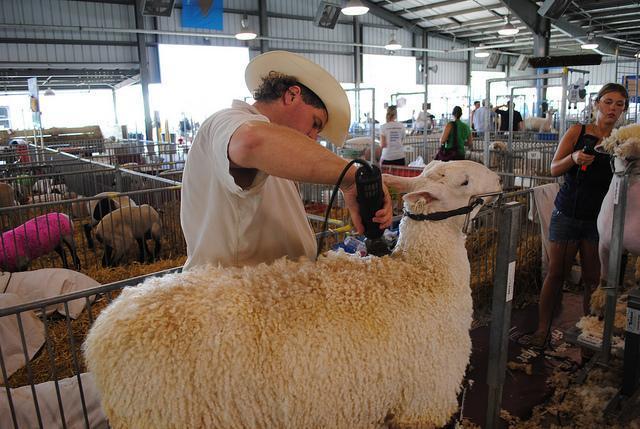How many sheep are in the photo?
Give a very brief answer. 5. How many people are in the picture?
Give a very brief answer. 2. How many vases glass vases are on the table?
Give a very brief answer. 0. 